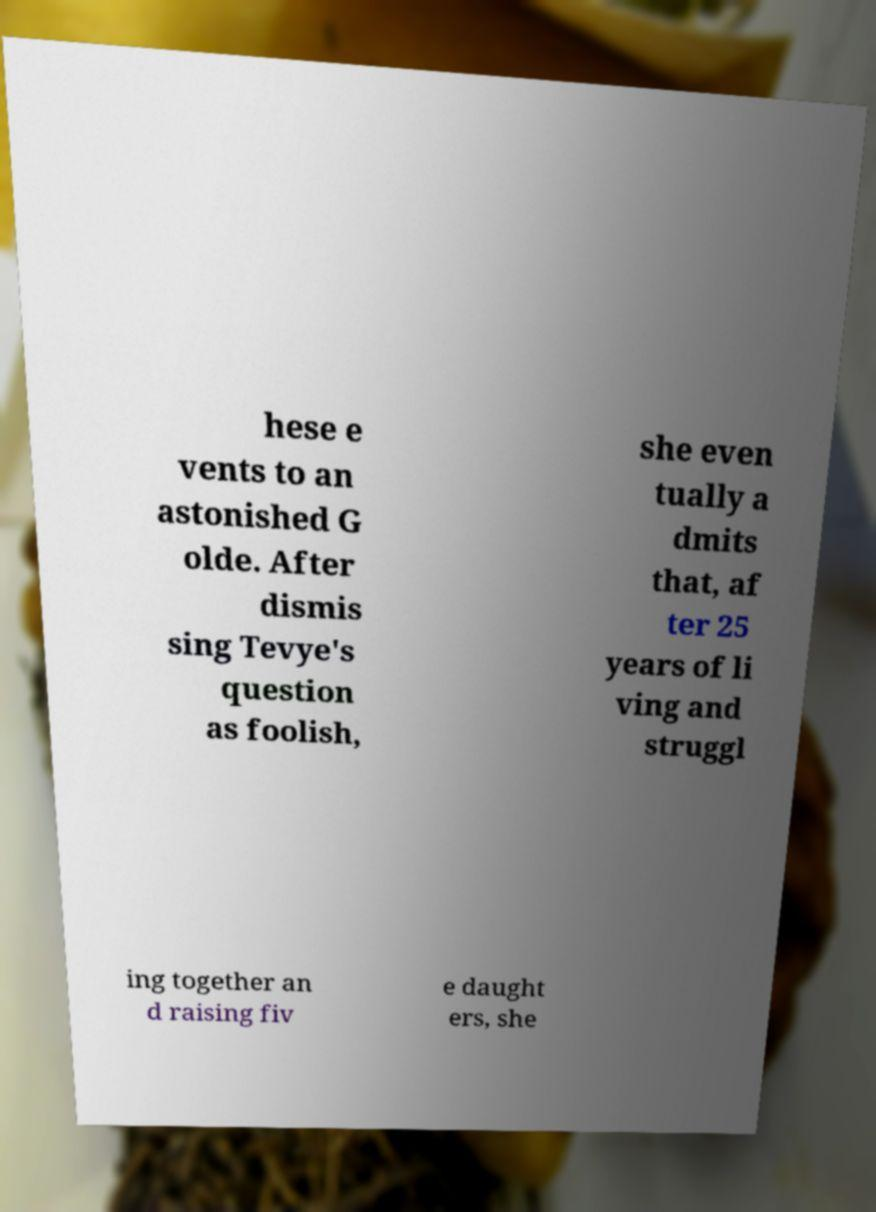Could you assist in decoding the text presented in this image and type it out clearly? hese e vents to an astonished G olde. After dismis sing Tevye's question as foolish, she even tually a dmits that, af ter 25 years of li ving and struggl ing together an d raising fiv e daught ers, she 